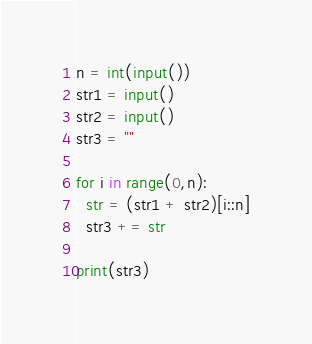Convert code to text. <code><loc_0><loc_0><loc_500><loc_500><_Python_>n = int(input())
str1 = input()
str2 = input()
str3 = ""

for i in range(0,n):
  str = (str1 + str2)[i::n]
  str3 += str

print(str3)</code> 